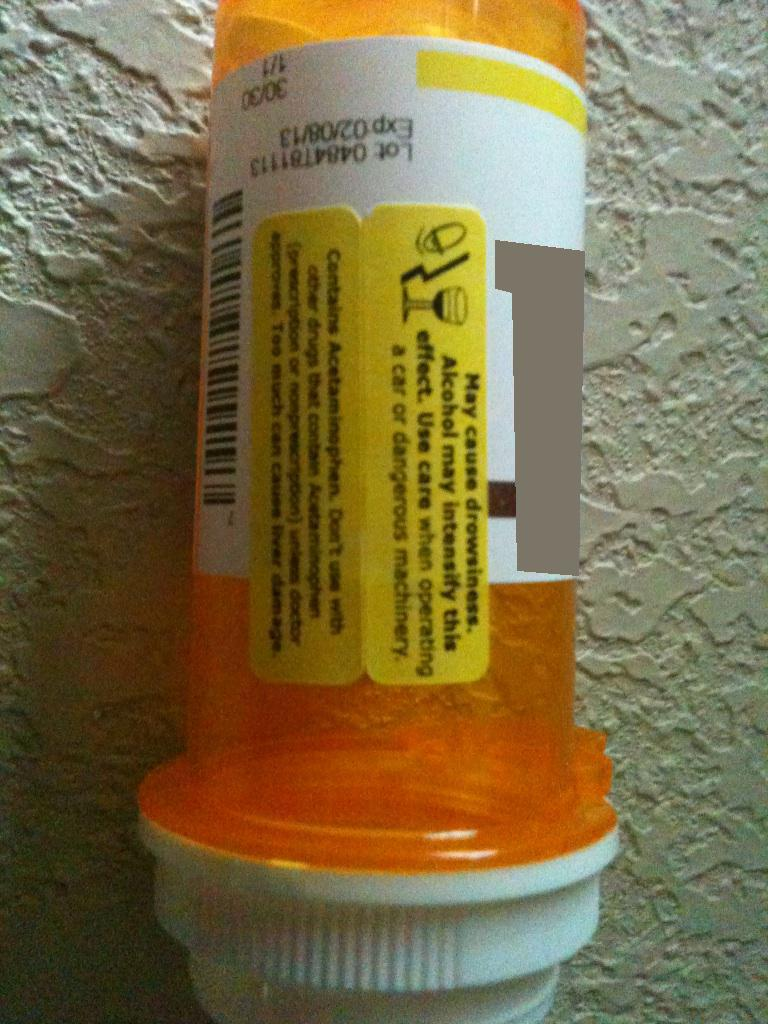Can you explain the significance of acetaminophen in this medication? Acetaminophen is a commonly used pain reliever and fever reducer. It’s an active ingredient in many over-the-counter and prescription medications. The significance of acetaminophen in this medication is to help alleviate pain and reduce fever. However, it's crucial to follow dosing guidelines because excessive consumption can lead to liver damage. Caution is warranted when combining this medication with others that contain acetaminophen to avoid unintentional overdose. 